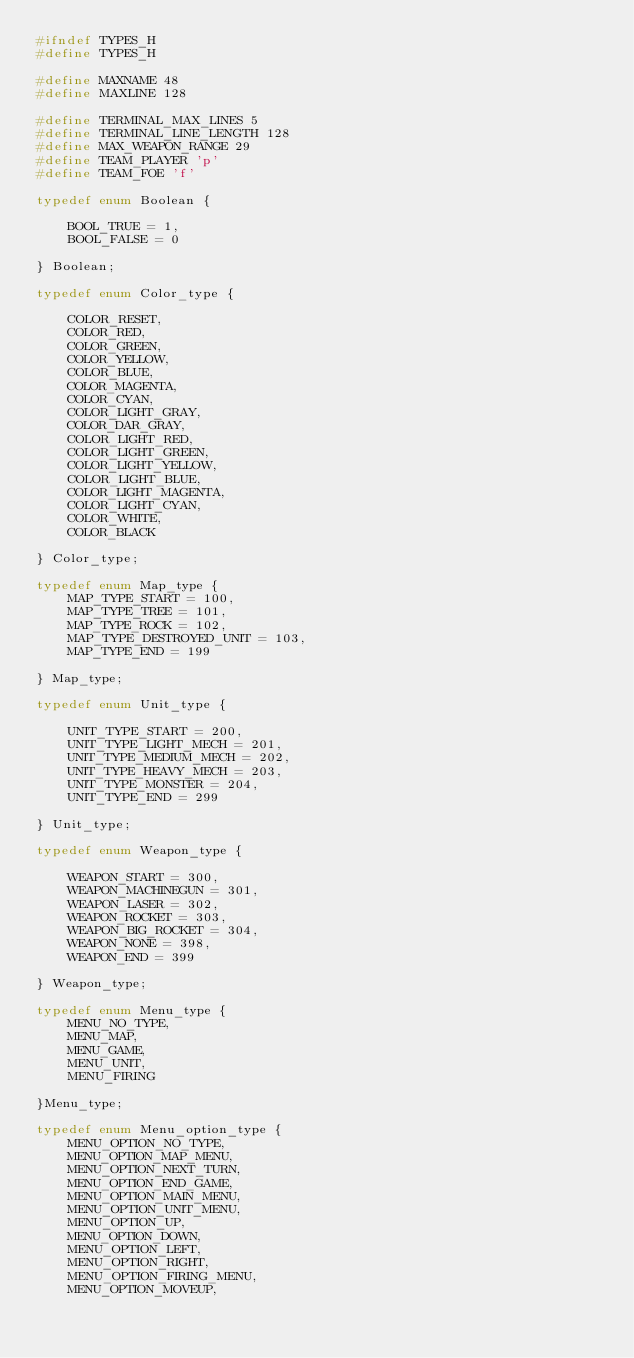Convert code to text. <code><loc_0><loc_0><loc_500><loc_500><_C_>#ifndef TYPES_H
#define TYPES_H

#define MAXNAME 48
#define MAXLINE 128

#define TERMINAL_MAX_LINES 5
#define TERMINAL_LINE_LENGTH 128
#define MAX_WEAPON_RANGE 29
#define TEAM_PLAYER 'p'
#define TEAM_FOE 'f'

typedef enum Boolean {

	BOOL_TRUE = 1,
	BOOL_FALSE = 0

} Boolean;

typedef enum Color_type {

	COLOR_RESET,
	COLOR_RED,
	COLOR_GREEN,
	COLOR_YELLOW,
	COLOR_BLUE,
	COLOR_MAGENTA,
	COLOR_CYAN,
	COLOR_LIGHT_GRAY,
	COLOR_DAR_GRAY,
	COLOR_LIGHT_RED,
	COLOR_LIGHT_GREEN,
	COLOR_LIGHT_YELLOW,
	COLOR_LIGHT_BLUE,
	COLOR_LIGHT_MAGENTA,
	COLOR_LIGHT_CYAN,
	COLOR_WHITE,
	COLOR_BLACK

} Color_type;

typedef enum Map_type {
	MAP_TYPE_START = 100,
	MAP_TYPE_TREE = 101,
	MAP_TYPE_ROCK = 102,
	MAP_TYPE_DESTROYED_UNIT = 103,
	MAP_TYPE_END = 199

} Map_type;

typedef enum Unit_type {

	UNIT_TYPE_START = 200, 
	UNIT_TYPE_LIGHT_MECH = 201, 	
	UNIT_TYPE_MEDIUM_MECH = 202,
	UNIT_TYPE_HEAVY_MECH = 203, 	
	UNIT_TYPE_MONSTER = 204,
	UNIT_TYPE_END = 299

} Unit_type;

typedef enum Weapon_type {

	WEAPON_START = 300,
	WEAPON_MACHINEGUN = 301,
	WEAPON_LASER = 302,
	WEAPON_ROCKET = 303,
	WEAPON_BIG_ROCKET = 304,
	WEAPON_NONE = 398,
	WEAPON_END = 399

} Weapon_type;

typedef enum Menu_type {
	MENU_NO_TYPE,
	MENU_MAP,
	MENU_GAME,
	MENU_UNIT,
	MENU_FIRING

}Menu_type;

typedef enum Menu_option_type {
	MENU_OPTION_NO_TYPE,
	MENU_OPTION_MAP_MENU,
	MENU_OPTION_NEXT_TURN,
	MENU_OPTION_END_GAME,
	MENU_OPTION_MAIN_MENU,
	MENU_OPTION_UNIT_MENU,
	MENU_OPTION_UP,
	MENU_OPTION_DOWN,
	MENU_OPTION_LEFT,
	MENU_OPTION_RIGHT,
	MENU_OPTION_FIRING_MENU,
	MENU_OPTION_MOVEUP,</code> 